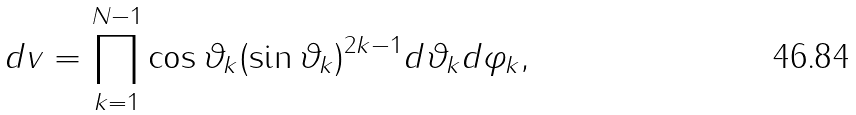<formula> <loc_0><loc_0><loc_500><loc_500>d v = \prod _ { k = 1 } ^ { N - 1 } \cos \vartheta _ { k } ( \sin \vartheta _ { k } ) ^ { 2 k - 1 } d \vartheta _ { k } d \varphi _ { k } ,</formula> 